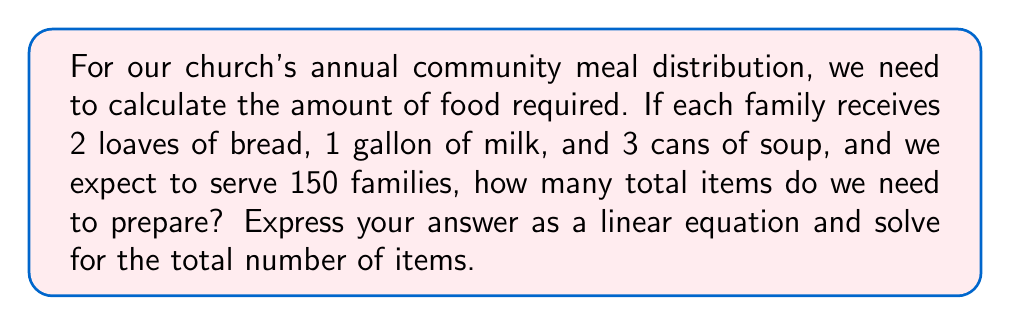Solve this math problem. Let's approach this step-by-step:

1) First, let's define our variables:
   $b$ = number of bread loaves
   $m$ = number of milk gallons
   $s$ = number of soup cans

2) We know that for each family:
   $b = 2$
   $m = 1$
   $s = 3$

3) We need to multiply each of these by the number of families (150):
   Total bread loaves: $2 \times 150 = 300$
   Total milk gallons: $1 \times 150 = 150$
   Total soup cans: $3 \times 150 = 450$

4) Now, we can write our linear equation:
   $$T = 300b + 150m + 450s$$
   Where $T$ is the total number of items.

5) To solve for $T$, we simply need to add these numbers:
   $$T = 300 + 150 + 450 = 900$$

Therefore, the total number of items needed is 900.
Answer: $T = 300b + 150m + 450s = 900$ items 